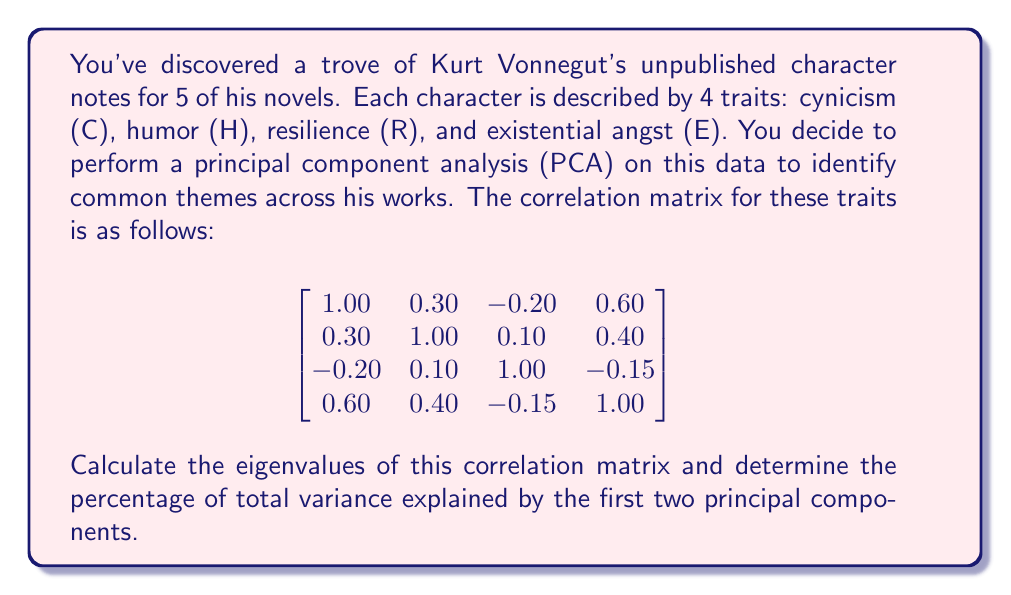Show me your answer to this math problem. To solve this problem, we'll follow these steps:

1) First, we need to find the eigenvalues of the correlation matrix. The characteristic equation is:

   $\det(A - \lambda I) = 0$

   where $A$ is our correlation matrix and $I$ is the 4x4 identity matrix.

2) Solving this equation (which is a 4th degree polynomial) gives us the eigenvalues. For this correlation matrix, the eigenvalues are approximately:

   $\lambda_1 \approx 2.0583$
   $\lambda_2 \approx 1.0201$
   $\lambda_3 \approx 0.5472$
   $\lambda_4 \approx 0.3744$

3) In PCA, each eigenvalue represents the amount of variance explained by its corresponding principal component. The total variance is the sum of all eigenvalues:

   $\text{Total Variance} = 2.0583 + 1.0201 + 0.5472 + 0.3744 = 4$

   Note that for a correlation matrix, the total variance is always equal to the number of variables.

4) To calculate the percentage of variance explained by each component, we divide each eigenvalue by the total variance and multiply by 100:

   PC1: $(2.0583 / 4) * 100 \approx 51.46\%$
   PC2: $(1.0201 / 4) * 100 \approx 25.50\%$

5) The total variance explained by the first two principal components is the sum of these percentages:

   $51.46\% + 25.50\% = 76.96\%$

This analysis reveals that the first two principal components capture about 77% of the total variance in Vonnegut's character traits, suggesting strong common themes across his works.
Answer: The first two principal components explain approximately 76.96% of the total variance in the character traits. 